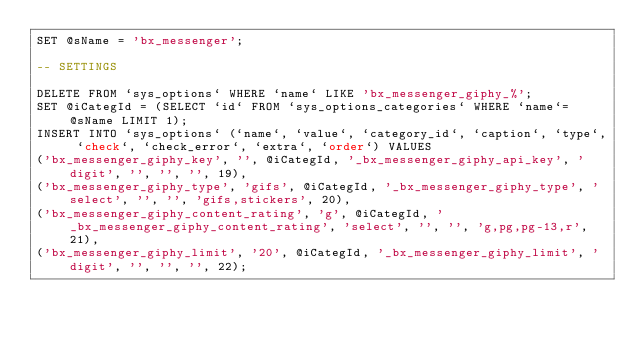Convert code to text. <code><loc_0><loc_0><loc_500><loc_500><_SQL_>SET @sName = 'bx_messenger';

-- SETTINGS

DELETE FROM `sys_options` WHERE `name` LIKE 'bx_messenger_giphy_%';
SET @iCategId = (SELECT `id` FROM `sys_options_categories` WHERE `name`=@sName LIMIT 1);
INSERT INTO `sys_options` (`name`, `value`, `category_id`, `caption`, `type`, `check`, `check_error`, `extra`, `order`) VALUES
('bx_messenger_giphy_key', '', @iCategId, '_bx_messenger_giphy_api_key', 'digit', '', '', '', 19),
('bx_messenger_giphy_type', 'gifs', @iCategId, '_bx_messenger_giphy_type', 'select', '', '', 'gifs,stickers', 20),
('bx_messenger_giphy_content_rating', 'g', @iCategId, '_bx_messenger_giphy_content_rating', 'select', '', '', 'g,pg,pg-13,r', 21),
('bx_messenger_giphy_limit', '20', @iCategId, '_bx_messenger_giphy_limit', 'digit', '', '', '', 22);</code> 